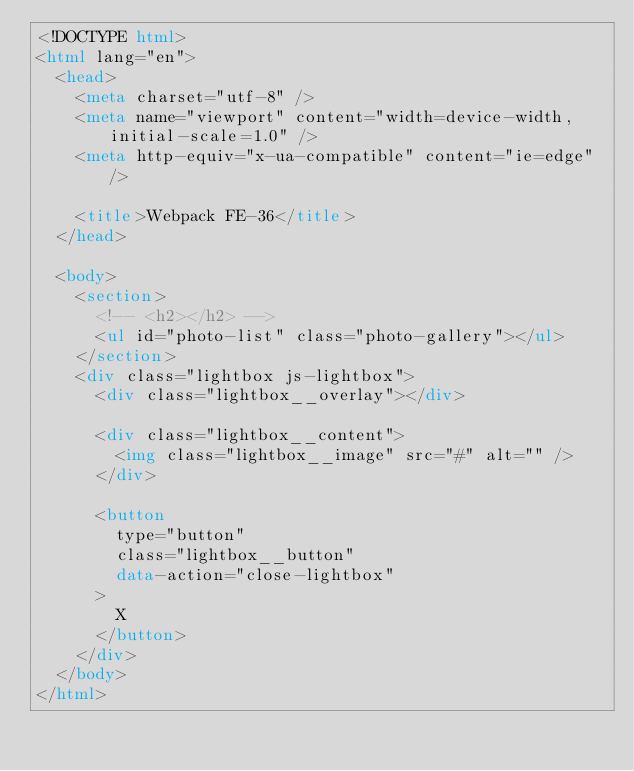<code> <loc_0><loc_0><loc_500><loc_500><_HTML_><!DOCTYPE html>
<html lang="en">
  <head>
    <meta charset="utf-8" />
    <meta name="viewport" content="width=device-width, initial-scale=1.0" />
    <meta http-equiv="x-ua-compatible" content="ie=edge" />

    <title>Webpack FE-36</title>
  </head>

  <body>
    <section>
      <!-- <h2></h2> -->
      <ul id="photo-list" class="photo-gallery"></ul>
    </section>
    <div class="lightbox js-lightbox">
      <div class="lightbox__overlay"></div>

      <div class="lightbox__content">
        <img class="lightbox__image" src="#" alt="" />
      </div>

      <button
        type="button"
        class="lightbox__button"
        data-action="close-lightbox"
      >
        X
      </button>
    </div>
  </body>
</html>
</code> 